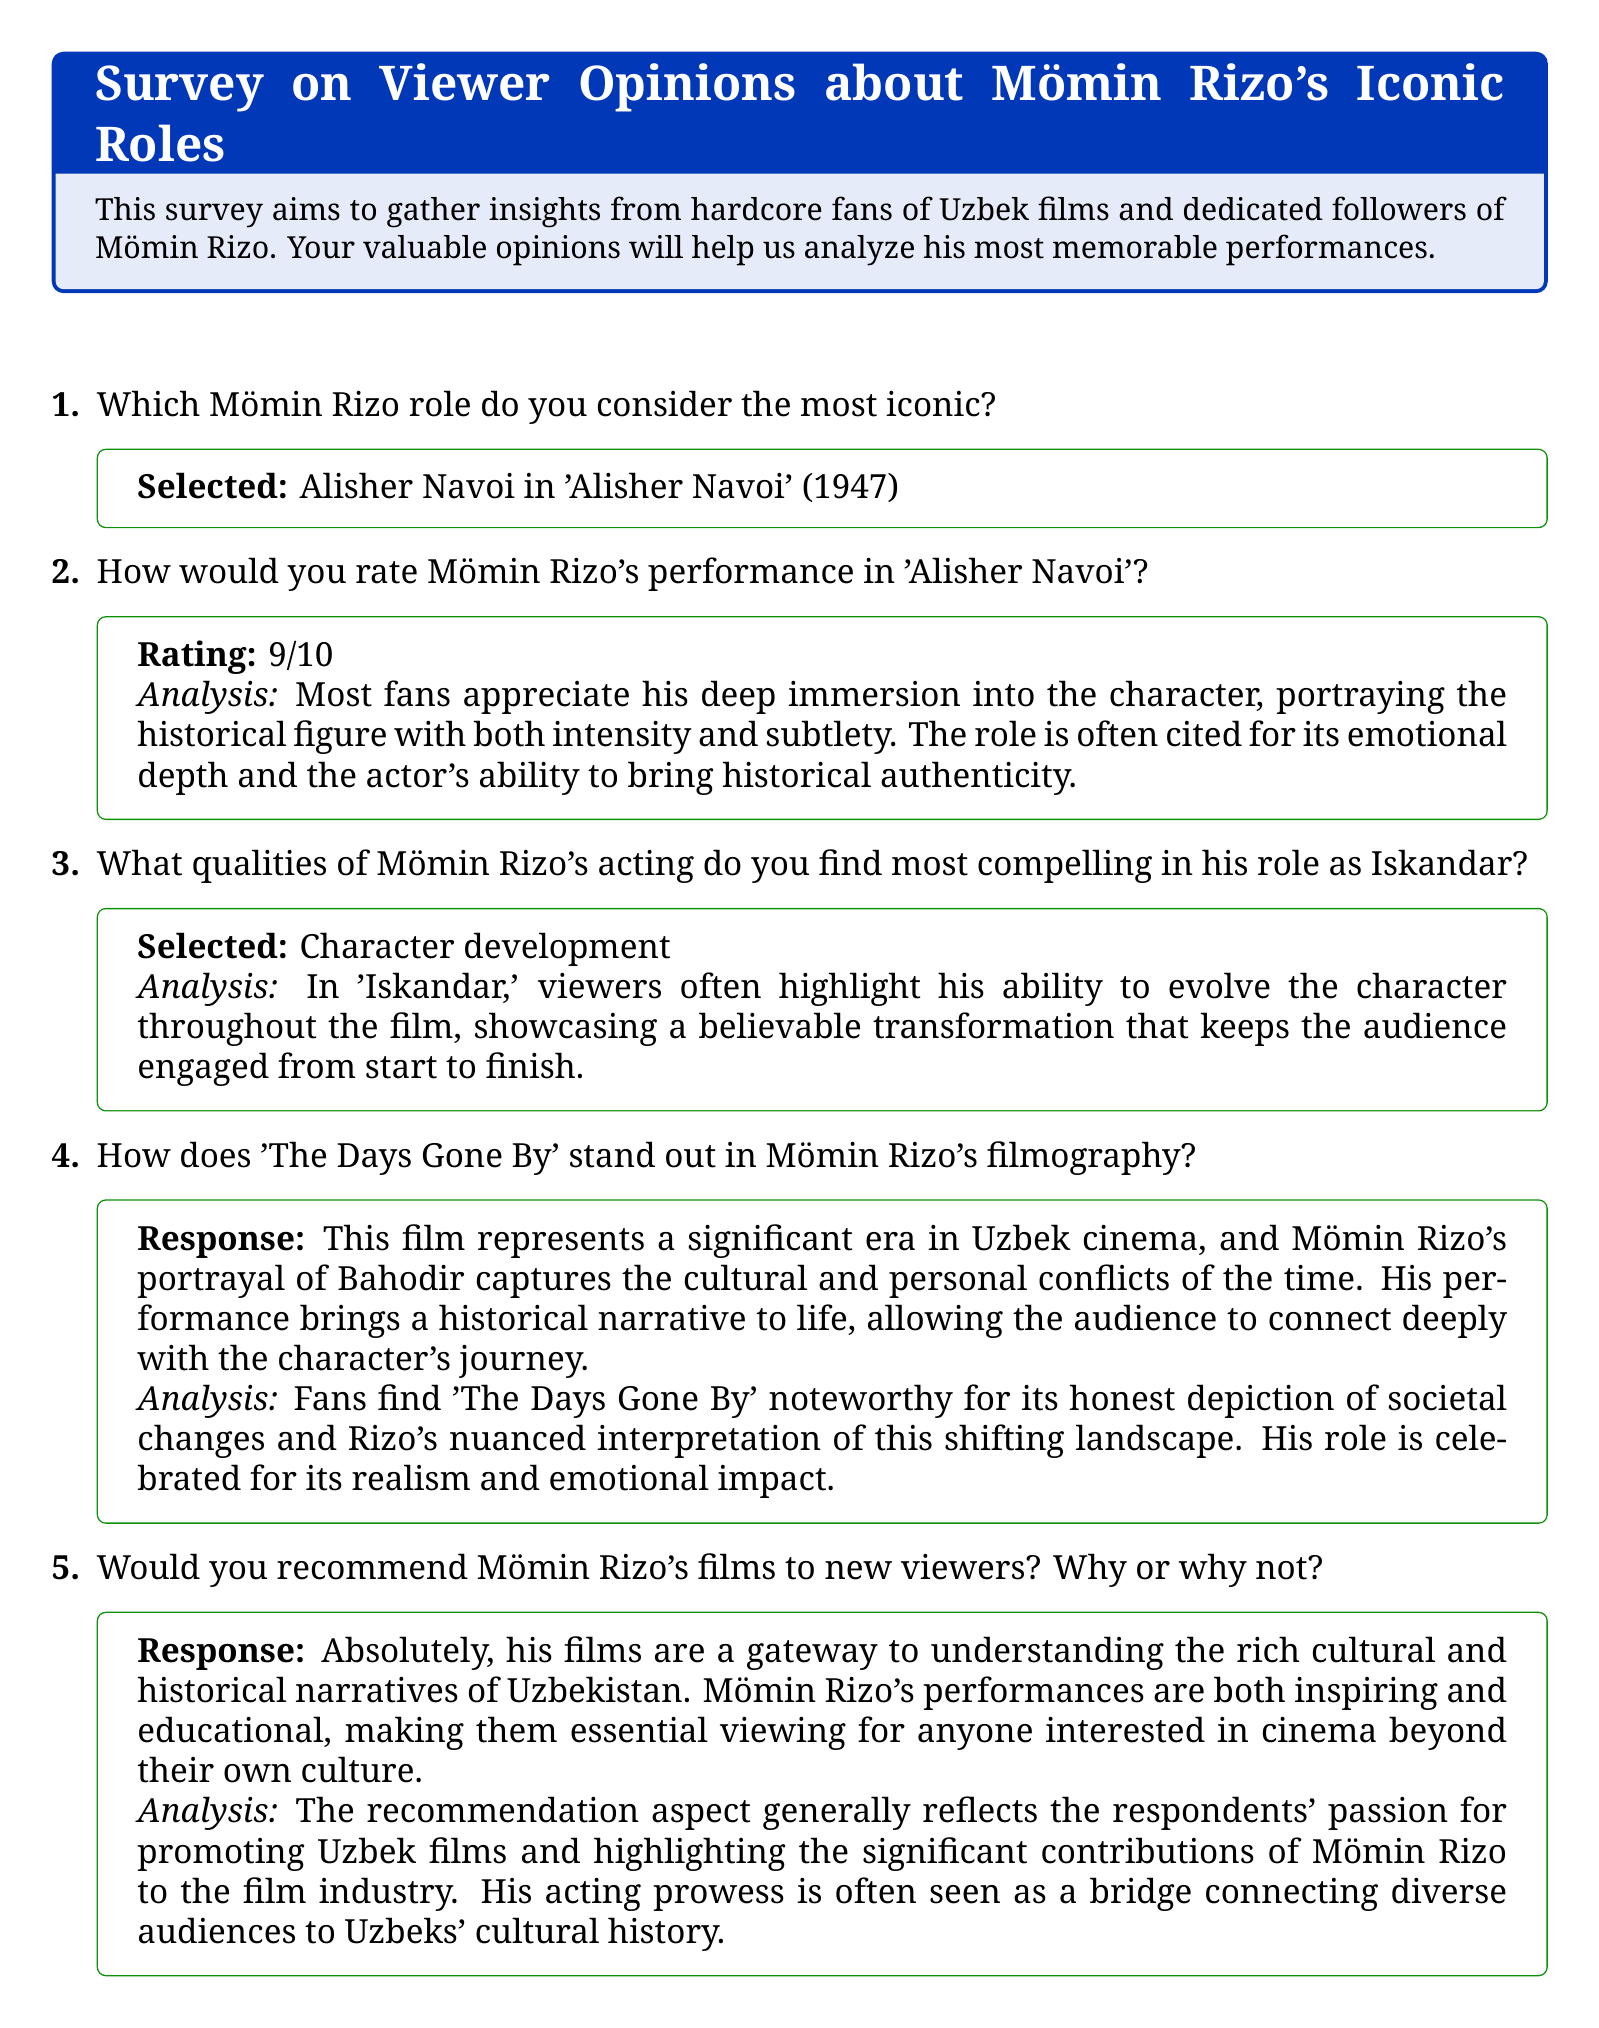Which role is considered the most iconic? The document states that the selected role is Alisher Navoi in 'Alisher Navoi' (1947), which reflects the opinions of the respondents.
Answer: Alisher Navoi in 'Alisher Navoi' (1947) What rating did fans give Mömin Rizo's performance in 'Alisher Navoi'? According to the document, the performance was rated 9/10 by the fans, indicating a strong appreciation for his acting.
Answer: 9/10 What quality was highlighted in Mömin Rizo's acting as Iskandar? The respondents pointed out character development as the compelling quality, showcasing a believable transformation throughout the film.
Answer: Character development How is 'The Days Gone By' perceived in Mömin Rizo's filmography? The document mentions that this film captures cultural and personal conflicts of the time, marking its significance in Uzbek cinema through Rizo's portrayal of Bahodir.
Answer: A significant era in Uzbek cinema Would fans recommend Mömin Rizo's films to new viewers? Fans answered affirmatively in the survey, emphasizing the cultural and historical importance of Rizo's films.
Answer: Absolutely 